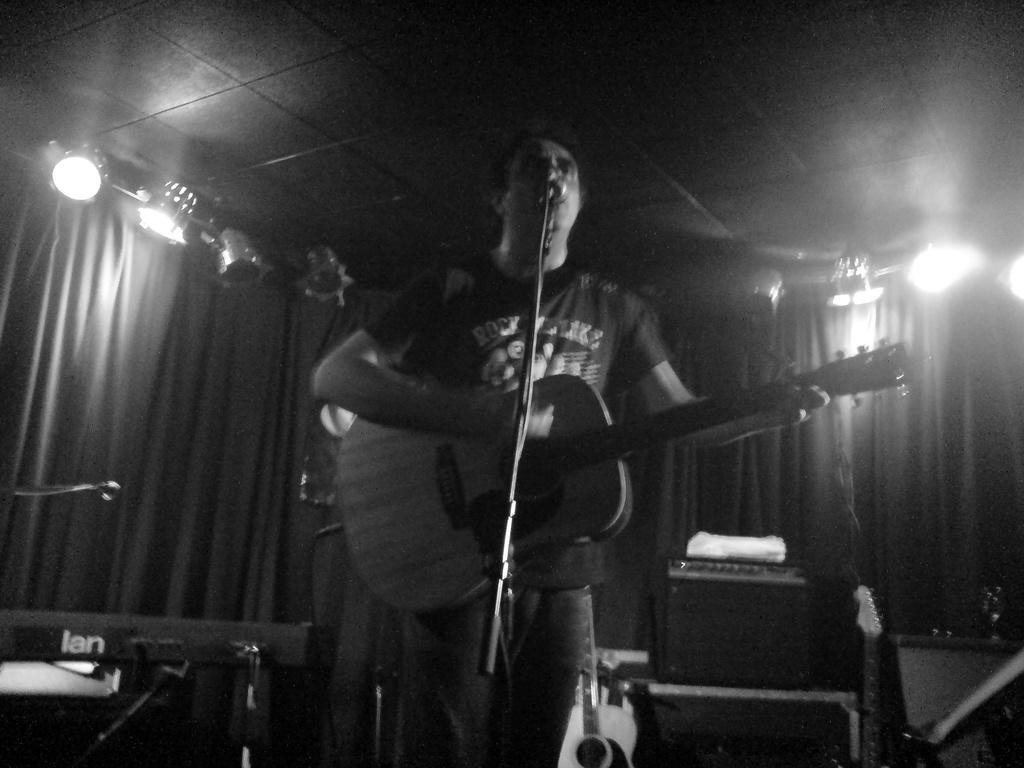What is the man in the image doing? The man is playing a guitar. What is the man positioned in front of? The man is in front of a microphone. What musical instrument can be seen in the background of the image? There is a piano in the background of the image. What equipment is present in the background of the image? There are speakers in the background of the image. What type of window treatment is visible in the image? There are curtains visible in the image. What type of lighting is present in the image? There are lights visible in the image. What type of blood is visible on the quilt in the image? There is no blood or quilt present in the image. 